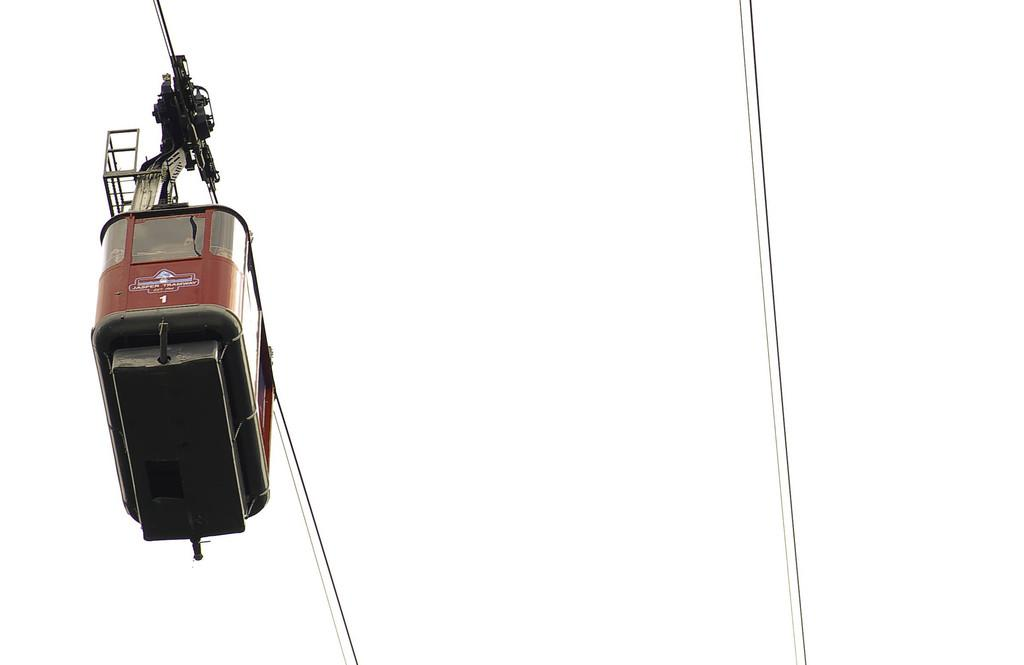What is the main subject of the image? The main subject of the image is a ropeway wheel car. Can you describe the appearance of the ropeway wheel car? Unfortunately, the appearance of the ropeway wheel car cannot be described in detail based on the provided fact. How many giraffes can be seen in the image? There are no giraffes present in the image. What type of spot is visible on the ropeway wheel car? There is no information about any spots on the ropeway wheel car in the provided fact. 